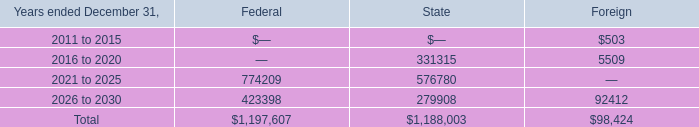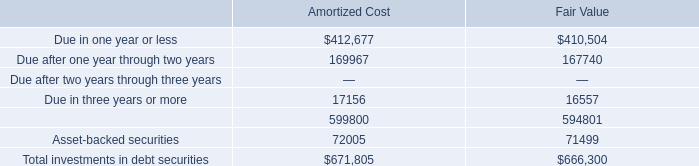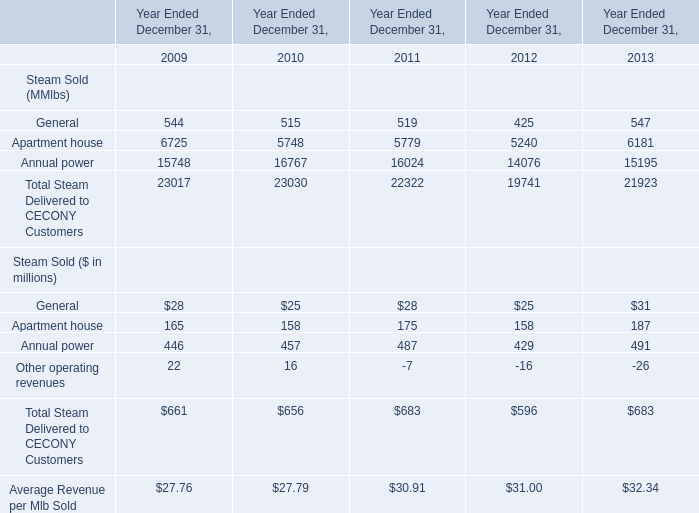at december 2010 what was the percent of the losses related to employee stock options included in the net federal operating loss carry forwards 
Computations: (0.3 / 1.2)
Answer: 0.25. 